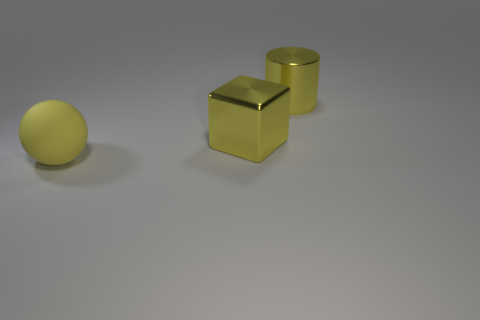Is there anything else that is the same material as the sphere?
Ensure brevity in your answer.  No. Does the large matte ball have the same color as the metal object on the left side of the big yellow metal cylinder?
Your response must be concise. Yes. How many cyan metallic things are there?
Provide a succinct answer. 0. How many things are large yellow blocks or cyan things?
Give a very brief answer. 1. What size is the shiny cylinder that is the same color as the ball?
Your response must be concise. Large. There is a big yellow rubber object; are there any matte balls to the left of it?
Offer a very short reply. No. Is the number of large yellow matte things that are in front of the cylinder greater than the number of metallic cylinders in front of the matte thing?
Offer a terse response. Yes. What number of spheres are either yellow shiny objects or big blue rubber things?
Your response must be concise. 0. There is a large ball that is the same color as the large shiny cube; what material is it?
Give a very brief answer. Rubber. Is the number of yellow metallic cubes left of the large yellow ball less than the number of yellow blocks on the right side of the large yellow metal cube?
Your answer should be compact. No. 